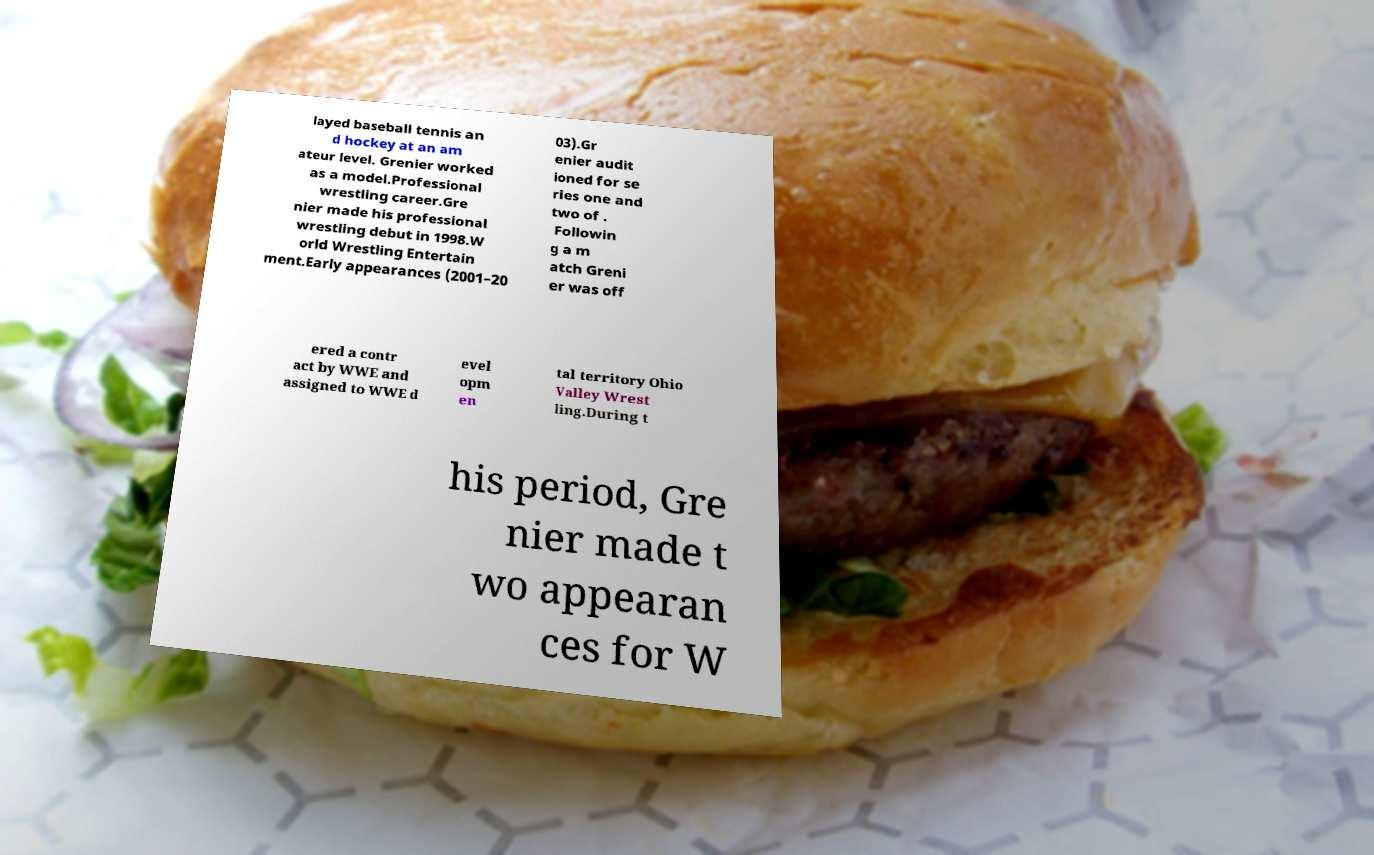Please identify and transcribe the text found in this image. layed baseball tennis an d hockey at an am ateur level. Grenier worked as a model.Professional wrestling career.Gre nier made his professional wrestling debut in 1998.W orld Wrestling Entertain ment.Early appearances (2001–20 03).Gr enier audit ioned for se ries one and two of . Followin g a m atch Greni er was off ered a contr act by WWE and assigned to WWE d evel opm en tal territory Ohio Valley Wrest ling.During t his period, Gre nier made t wo appearan ces for W 